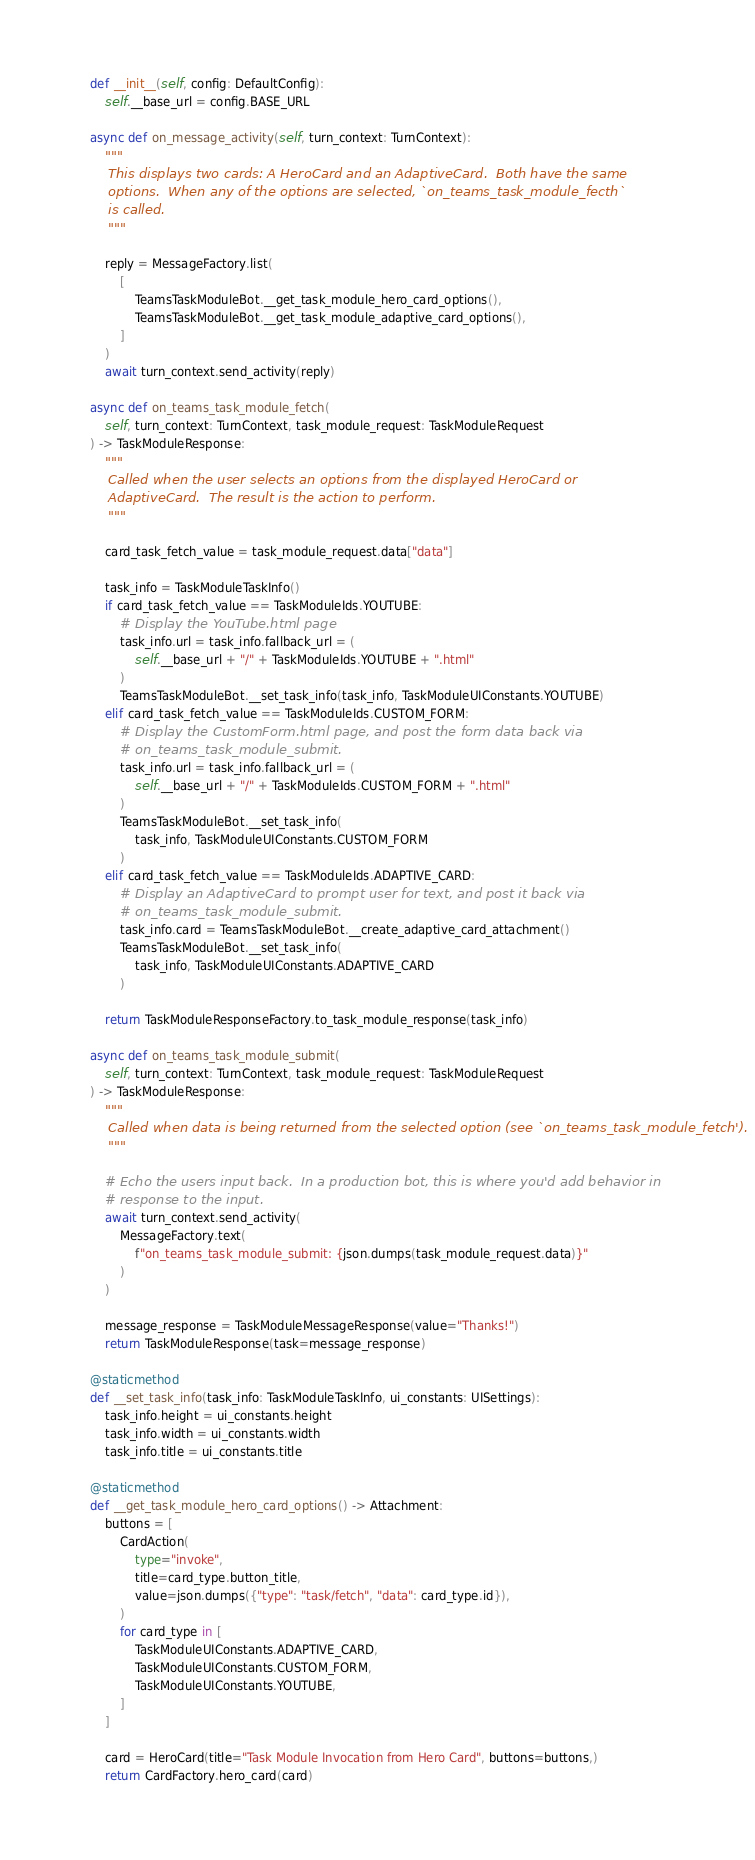<code> <loc_0><loc_0><loc_500><loc_500><_Python_>    def __init__(self, config: DefaultConfig):
        self.__base_url = config.BASE_URL

    async def on_message_activity(self, turn_context: TurnContext):
        """
        This displays two cards: A HeroCard and an AdaptiveCard.  Both have the same
        options.  When any of the options are selected, `on_teams_task_module_fecth`
        is called.
        """

        reply = MessageFactory.list(
            [
                TeamsTaskModuleBot.__get_task_module_hero_card_options(),
                TeamsTaskModuleBot.__get_task_module_adaptive_card_options(),
            ]
        )
        await turn_context.send_activity(reply)

    async def on_teams_task_module_fetch(
        self, turn_context: TurnContext, task_module_request: TaskModuleRequest
    ) -> TaskModuleResponse:
        """
        Called when the user selects an options from the displayed HeroCard or
        AdaptiveCard.  The result is the action to perform.
        """

        card_task_fetch_value = task_module_request.data["data"]

        task_info = TaskModuleTaskInfo()
        if card_task_fetch_value == TaskModuleIds.YOUTUBE:
            # Display the YouTube.html page
            task_info.url = task_info.fallback_url = (
                self.__base_url + "/" + TaskModuleIds.YOUTUBE + ".html"
            )
            TeamsTaskModuleBot.__set_task_info(task_info, TaskModuleUIConstants.YOUTUBE)
        elif card_task_fetch_value == TaskModuleIds.CUSTOM_FORM:
            # Display the CustomForm.html page, and post the form data back via
            # on_teams_task_module_submit.
            task_info.url = task_info.fallback_url = (
                self.__base_url + "/" + TaskModuleIds.CUSTOM_FORM + ".html"
            )
            TeamsTaskModuleBot.__set_task_info(
                task_info, TaskModuleUIConstants.CUSTOM_FORM
            )
        elif card_task_fetch_value == TaskModuleIds.ADAPTIVE_CARD:
            # Display an AdaptiveCard to prompt user for text, and post it back via
            # on_teams_task_module_submit.
            task_info.card = TeamsTaskModuleBot.__create_adaptive_card_attachment()
            TeamsTaskModuleBot.__set_task_info(
                task_info, TaskModuleUIConstants.ADAPTIVE_CARD
            )

        return TaskModuleResponseFactory.to_task_module_response(task_info)

    async def on_teams_task_module_submit(
        self, turn_context: TurnContext, task_module_request: TaskModuleRequest
    ) -> TaskModuleResponse:
        """
        Called when data is being returned from the selected option (see `on_teams_task_module_fetch').
        """

        # Echo the users input back.  In a production bot, this is where you'd add behavior in
        # response to the input.
        await turn_context.send_activity(
            MessageFactory.text(
                f"on_teams_task_module_submit: {json.dumps(task_module_request.data)}"
            )
        )

        message_response = TaskModuleMessageResponse(value="Thanks!")
        return TaskModuleResponse(task=message_response)

    @staticmethod
    def __set_task_info(task_info: TaskModuleTaskInfo, ui_constants: UISettings):
        task_info.height = ui_constants.height
        task_info.width = ui_constants.width
        task_info.title = ui_constants.title

    @staticmethod
    def __get_task_module_hero_card_options() -> Attachment:
        buttons = [
            CardAction(
                type="invoke",
                title=card_type.button_title,
                value=json.dumps({"type": "task/fetch", "data": card_type.id}),
            )
            for card_type in [
                TaskModuleUIConstants.ADAPTIVE_CARD,
                TaskModuleUIConstants.CUSTOM_FORM,
                TaskModuleUIConstants.YOUTUBE,
            ]
        ]

        card = HeroCard(title="Task Module Invocation from Hero Card", buttons=buttons,)
        return CardFactory.hero_card(card)
</code> 